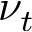<formula> <loc_0><loc_0><loc_500><loc_500>\nu _ { t }</formula> 